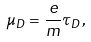Convert formula to latex. <formula><loc_0><loc_0><loc_500><loc_500>\mu _ { D } = \frac { e } { m } \tau _ { D } ,</formula> 